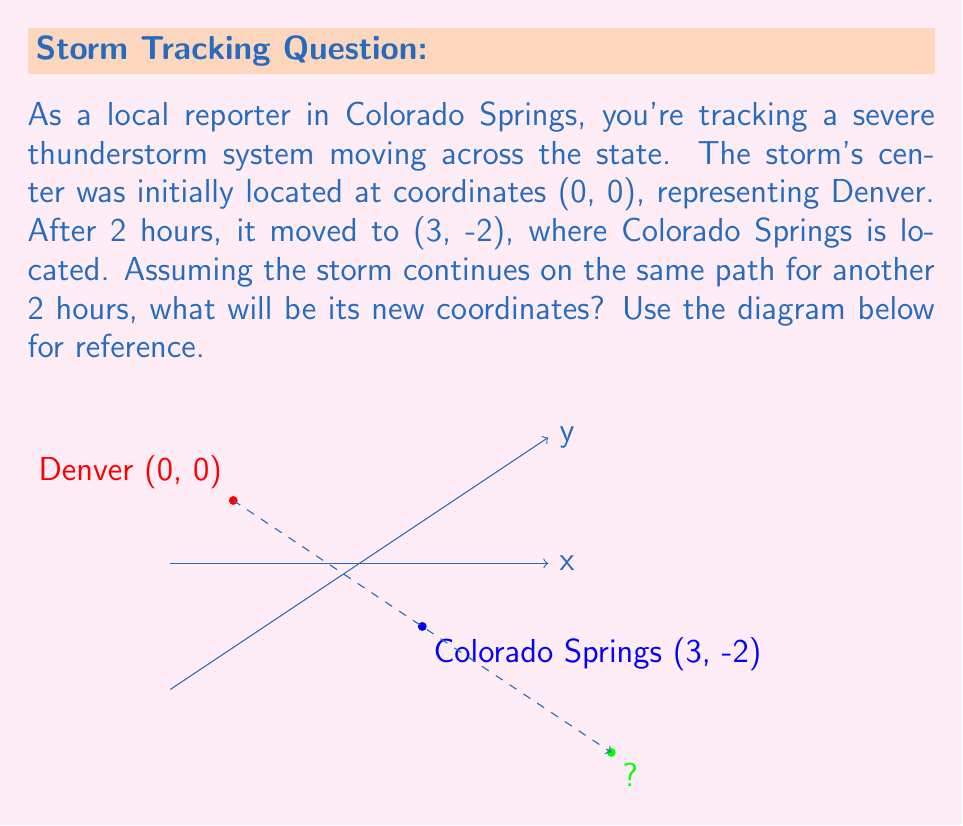Show me your answer to this math problem. To solve this problem, we need to follow these steps:

1. Determine the storm's movement vector:
   The storm moved from (0, 0) to (3, -2) in 2 hours.
   Movement vector = $$(3-0, -2-0) = (3, -2)$$

2. Calculate the rate of movement per hour:
   Rate = Movement / Time
   $$\text{Rate} = (3/2, -2/2) = (1.5, -1)$$ per hour

3. Predict the movement for the next 2 hours:
   Next 2 hours movement = Rate × Time
   $$\text{Next movement} = (1.5, -1) \times 2 = (3, -2)$$

4. Add this movement to the current position:
   New position = Current position + Next movement
   $$\text{New position} = (3, -2) + (3, -2) = (6, -4)$$

Therefore, after another 2 hours, the storm's center will be at coordinates (6, -4).
Answer: (6, -4) 